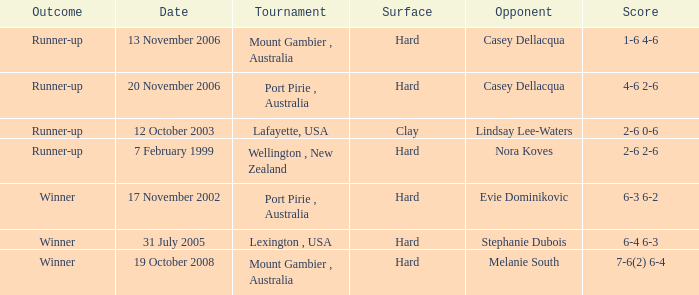When does evie dominikovic face an opponent? 17 November 2002. 